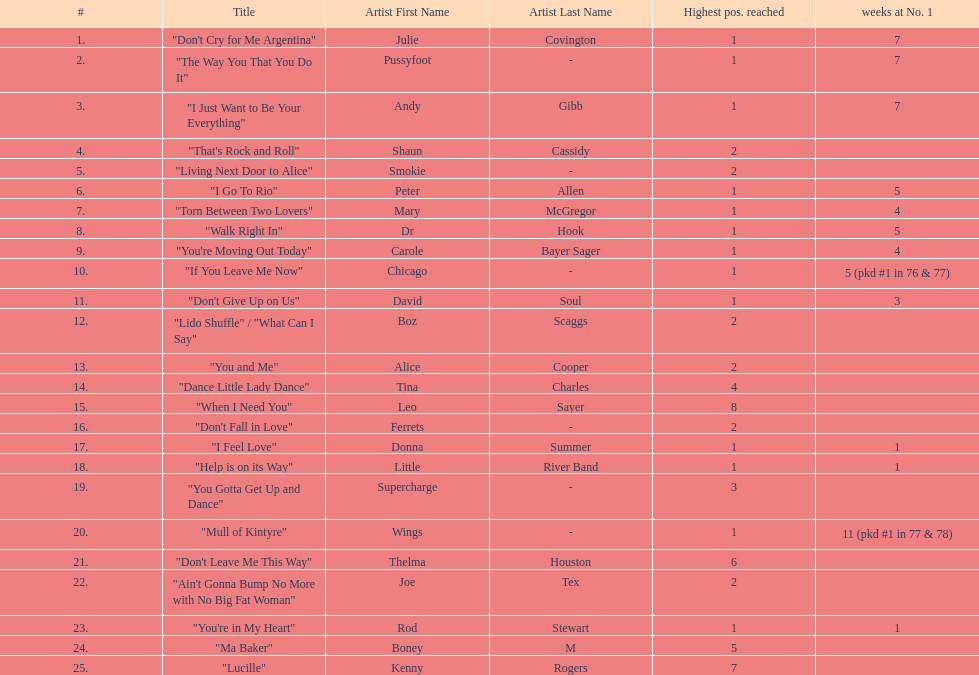How many weeks did julie covington's "don't cry for me argentina" spend at the top of australia's singles chart? 7. 